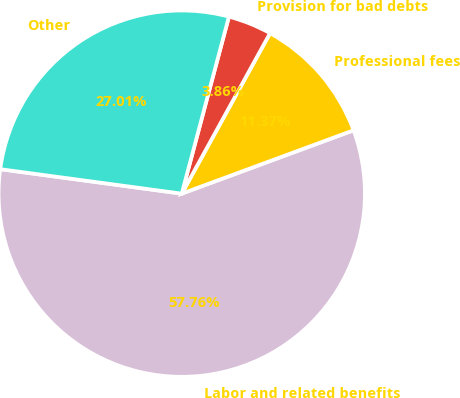<chart> <loc_0><loc_0><loc_500><loc_500><pie_chart><fcel>Labor and related benefits<fcel>Professional fees<fcel>Provision for bad debts<fcel>Other<nl><fcel>57.75%<fcel>11.37%<fcel>3.86%<fcel>27.01%<nl></chart> 